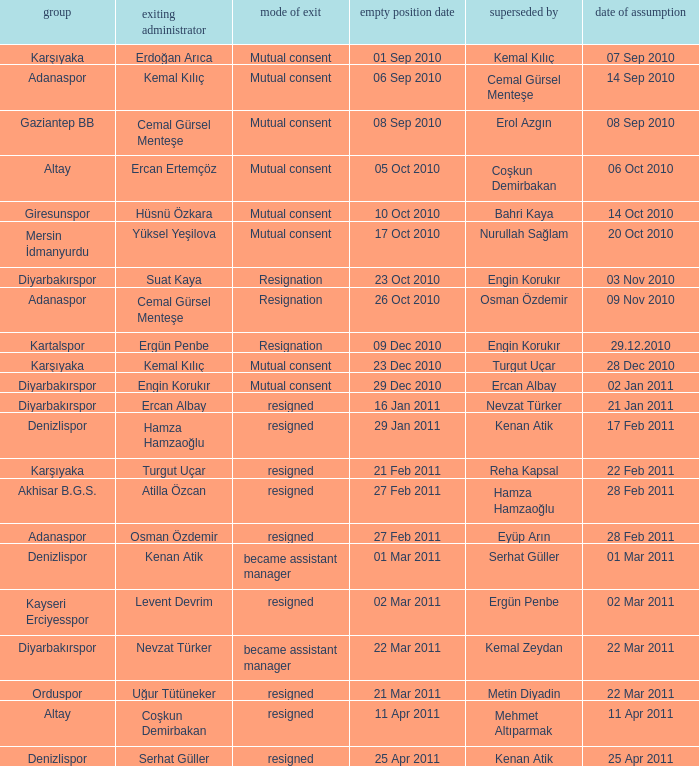Which team replaced their manager with Serhat Güller? Denizlispor. 